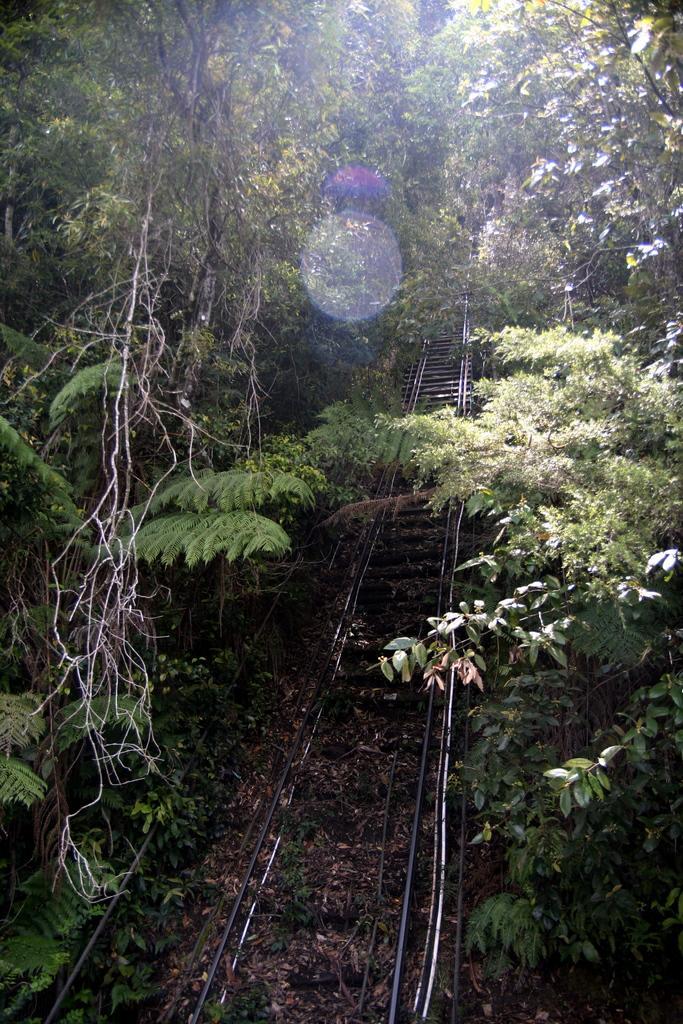Could you give a brief overview of what you see in this image? In this image in the center there is a railway track and there are trees. 